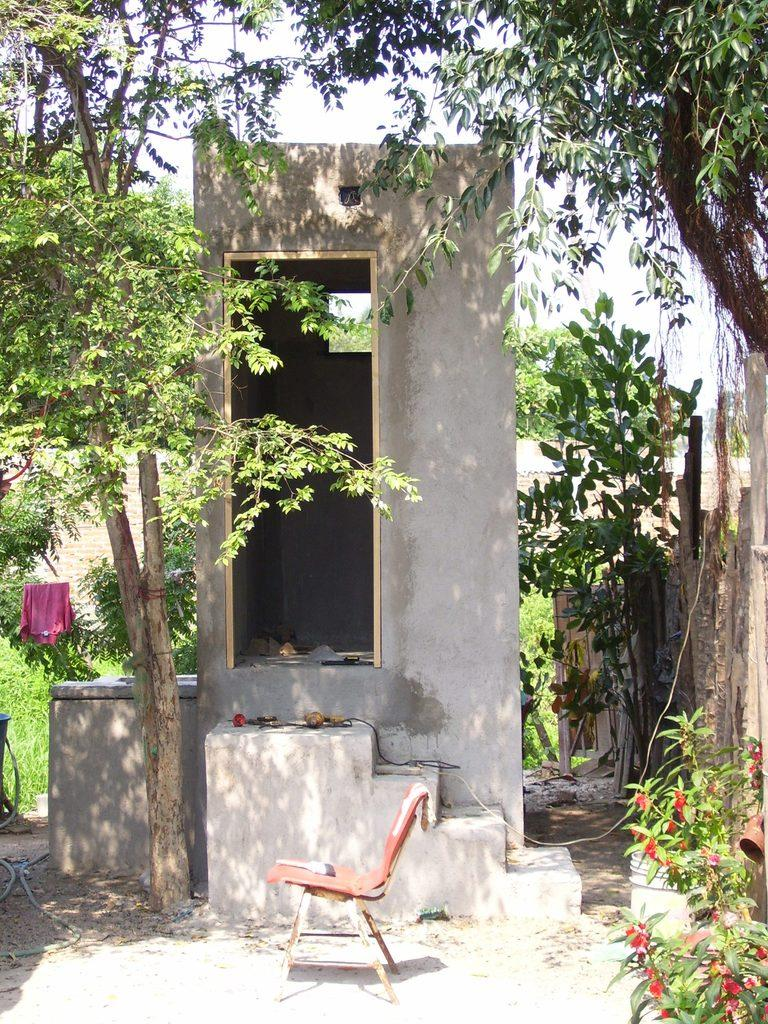What piece of furniture is present in the image? There is a chair in the image. What can be seen in the background of the image? There is a washroom and trees visible in the background of the image. Where is the plant located in the image? The plant is in the bottom right corner of the image. What type of smile can be seen on the plant in the image? There is no smile present in the image, as it features a chair, a washroom, trees, and a plant, but no faces or expressions. 